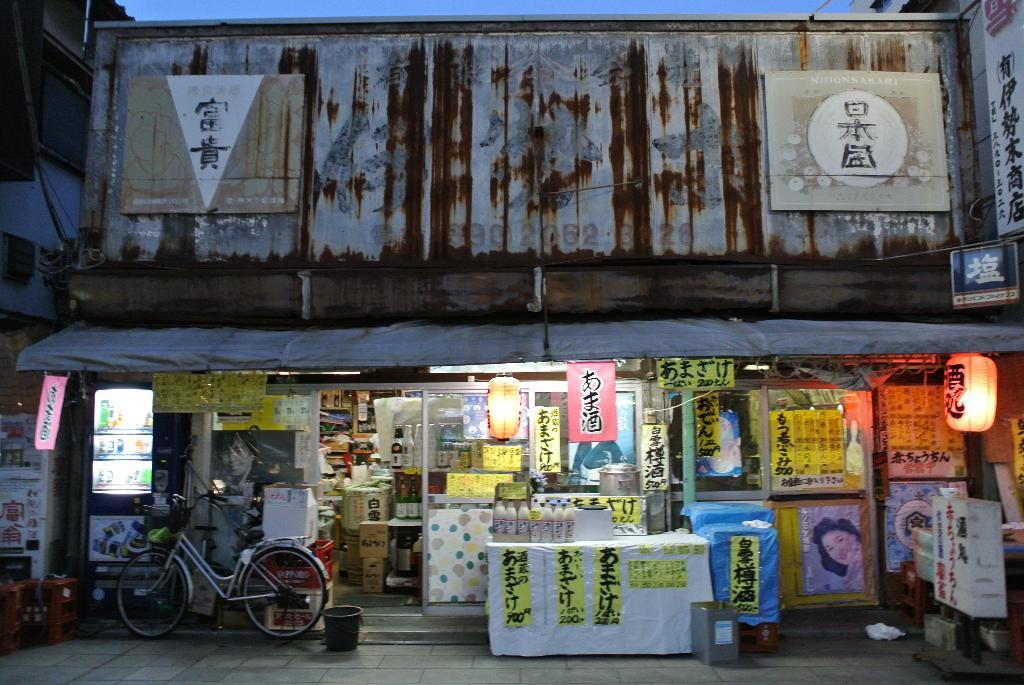Provide a one-sentence caption for the provided image. a bike next to a shop with Japanese writing. 